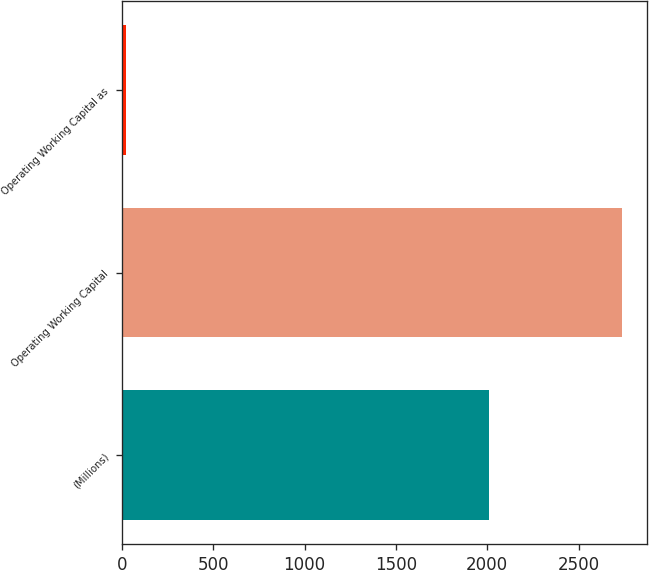<chart> <loc_0><loc_0><loc_500><loc_500><bar_chart><fcel>(Millions)<fcel>Operating Working Capital<fcel>Operating Working Capital as<nl><fcel>2011<fcel>2739<fcel>19.5<nl></chart> 